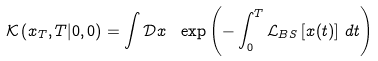Convert formula to latex. <formula><loc_0><loc_0><loc_500><loc_500>\mathcal { K } \left ( x _ { T } , T | 0 , 0 \right ) = \int \mathcal { D } x \text { } \exp \left ( - \int _ { 0 } ^ { T } \mathcal { L } _ { B S } \left [ x ( t ) \right ] \, d t \right )</formula> 